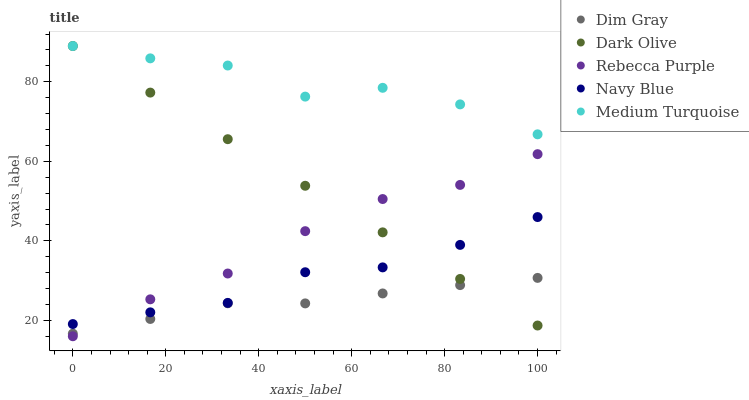Does Dim Gray have the minimum area under the curve?
Answer yes or no. Yes. Does Medium Turquoise have the maximum area under the curve?
Answer yes or no. Yes. Does Navy Blue have the minimum area under the curve?
Answer yes or no. No. Does Navy Blue have the maximum area under the curve?
Answer yes or no. No. Is Dark Olive the smoothest?
Answer yes or no. Yes. Is Medium Turquoise the roughest?
Answer yes or no. Yes. Is Navy Blue the smoothest?
Answer yes or no. No. Is Navy Blue the roughest?
Answer yes or no. No. Does Rebecca Purple have the lowest value?
Answer yes or no. Yes. Does Navy Blue have the lowest value?
Answer yes or no. No. Does Medium Turquoise have the highest value?
Answer yes or no. Yes. Does Navy Blue have the highest value?
Answer yes or no. No. Is Dim Gray less than Medium Turquoise?
Answer yes or no. Yes. Is Medium Turquoise greater than Dim Gray?
Answer yes or no. Yes. Does Dark Olive intersect Navy Blue?
Answer yes or no. Yes. Is Dark Olive less than Navy Blue?
Answer yes or no. No. Is Dark Olive greater than Navy Blue?
Answer yes or no. No. Does Dim Gray intersect Medium Turquoise?
Answer yes or no. No. 